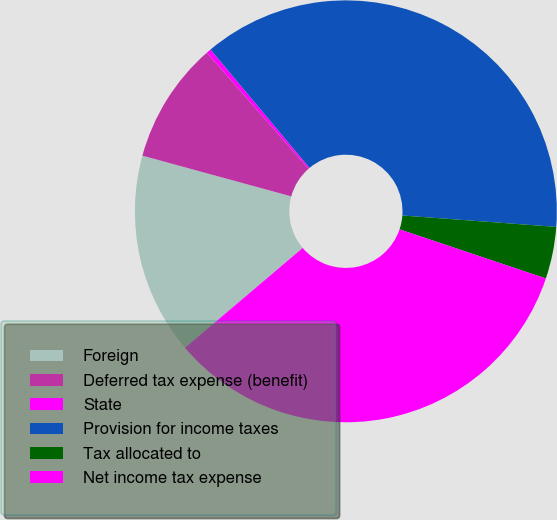<chart> <loc_0><loc_0><loc_500><loc_500><pie_chart><fcel>Foreign<fcel>Deferred tax expense (benefit)<fcel>State<fcel>Provision for income taxes<fcel>Tax allocated to<fcel>Net income tax expense<nl><fcel>15.45%<fcel>9.3%<fcel>0.36%<fcel>37.27%<fcel>3.98%<fcel>33.65%<nl></chart> 